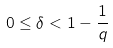Convert formula to latex. <formula><loc_0><loc_0><loc_500><loc_500>0 \leq \delta < 1 - \frac { 1 } { q }</formula> 